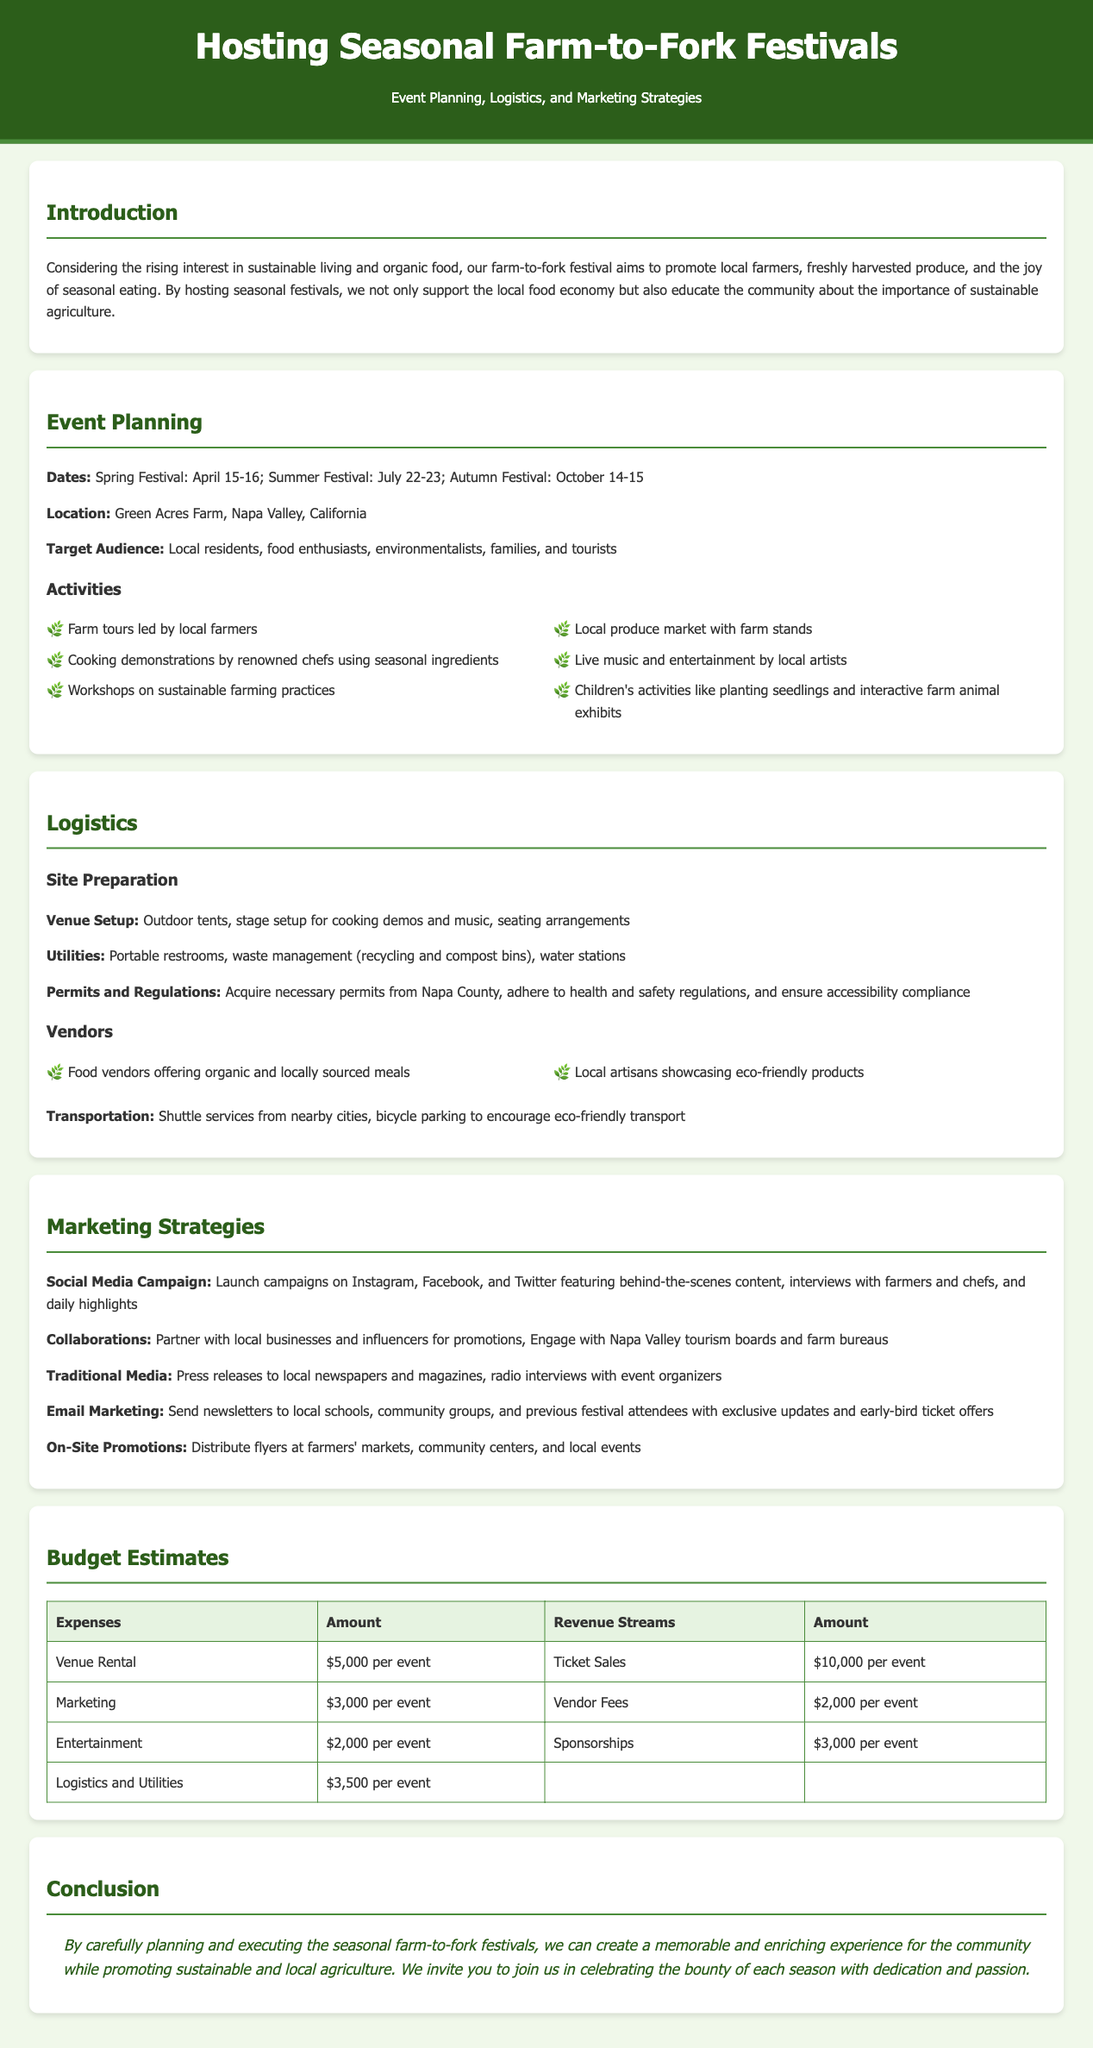What are the festival dates? The festival dates are specified in the Event Planning section, which includes the Spring Festival on April 15-16, Summer Festival on July 22-23, and Autumn Festival on October 14-15.
Answer: April 15-16, July 22-23, October 14-15 What is the venue for the festivals? The location of the festivals is mentioned under Event Planning, specifically indicating the venue as Green Acres Farm, Napa Valley, California.
Answer: Green Acres Farm, Napa Valley, California How many activities are listed for the festivals? The Events Planning section outlines six activities, which can be counted directly from the list provided.
Answer: 6 What type of transportation is encouraged? The Logistics section mentions "bicycle parking" as a means of encouraging eco-friendly transport, indicating the suggested transportation mode.
Answer: Bicycle parking What is the estimated cost for venue rental per event? The Budget Estimates section clearly states that the Venue Rental cost is $5,000 per event, providing a specific figure for this expense.
Answer: $5,000 per event What is the purpose of the farm-to-fork festivals? The Introduction section articulates the primary purpose of the festivals, which is to support local farmers and promote sustainable agriculture.
Answer: Promote local farmers and sustainable agriculture What are the revenue streams mentioned? The Budget Estimates section lists the revenue streams, which includes Ticket Sales, Vendor Fees, and Sponsorships, specifying how the event plans to generate income.
Answer: Ticket Sales, Vendor Fees, Sponsorships What is a marketing strategy used in promoting the festivals? The Marketing Strategies section describes a Social Media Campaign as one of the tactics used, highlighting the method for reaching potential attendees.
Answer: Social Media Campaign 